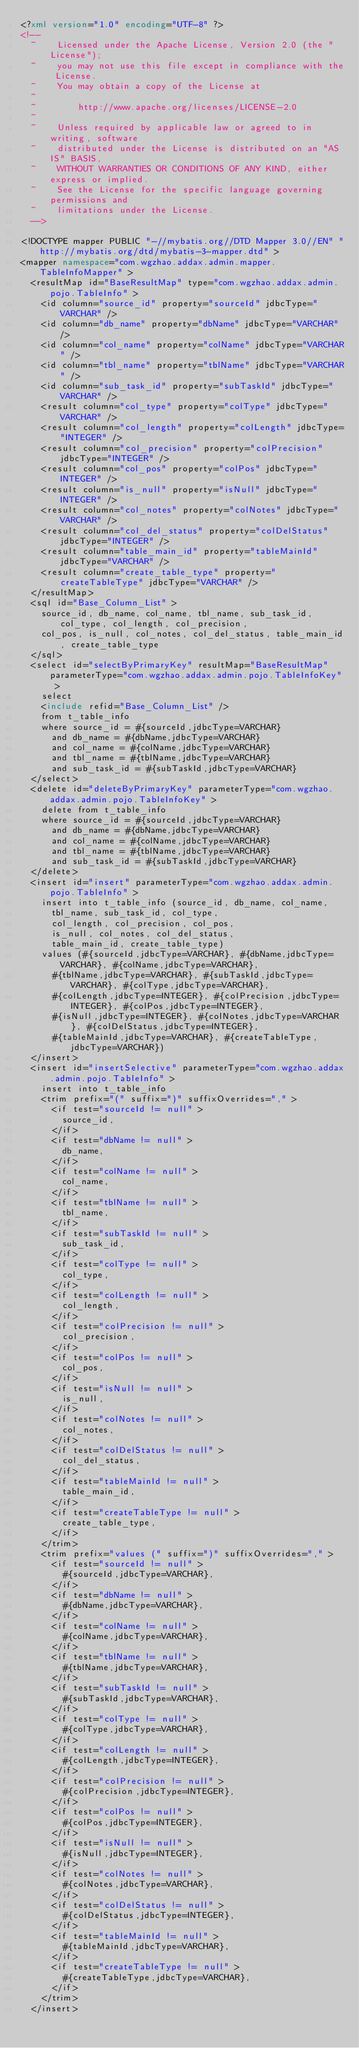Convert code to text. <code><loc_0><loc_0><loc_500><loc_500><_XML_><?xml version="1.0" encoding="UTF-8" ?>
<!--
  ~    Licensed under the Apache License, Version 2.0 (the "License");
  ~    you may not use this file except in compliance with the License.
  ~    You may obtain a copy of the License at
  ~
  ~        http://www.apache.org/licenses/LICENSE-2.0
  ~
  ~    Unless required by applicable law or agreed to in writing, software
  ~    distributed under the License is distributed on an "AS IS" BASIS,
  ~    WITHOUT WARRANTIES OR CONDITIONS OF ANY KIND, either express or implied.
  ~    See the License for the specific language governing permissions and
  ~    limitations under the License.
  -->

<!DOCTYPE mapper PUBLIC "-//mybatis.org//DTD Mapper 3.0//EN" "http://mybatis.org/dtd/mybatis-3-mapper.dtd" >
<mapper namespace="com.wgzhao.addax.admin.mapper.TableInfoMapper" >
  <resultMap id="BaseResultMap" type="com.wgzhao.addax.admin.pojo.TableInfo" >
    <id column="source_id" property="sourceId" jdbcType="VARCHAR" />
    <id column="db_name" property="dbName" jdbcType="VARCHAR" />
    <id column="col_name" property="colName" jdbcType="VARCHAR" />
    <id column="tbl_name" property="tblName" jdbcType="VARCHAR" />
    <id column="sub_task_id" property="subTaskId" jdbcType="VARCHAR" />
    <result column="col_type" property="colType" jdbcType="VARCHAR" />
    <result column="col_length" property="colLength" jdbcType="INTEGER" />
    <result column="col_precision" property="colPrecision" jdbcType="INTEGER" />
    <result column="col_pos" property="colPos" jdbcType="INTEGER" />
    <result column="is_null" property="isNull" jdbcType="INTEGER" />
    <result column="col_notes" property="colNotes" jdbcType="VARCHAR" />
    <result column="col_del_status" property="colDelStatus" jdbcType="INTEGER" />
    <result column="table_main_id" property="tableMainId" jdbcType="VARCHAR" />
    <result column="create_table_type" property="createTableType" jdbcType="VARCHAR" />
  </resultMap>
  <sql id="Base_Column_List" >
    source_id, db_name, col_name, tbl_name, sub_task_id, col_type, col_length, col_precision, 
    col_pos, is_null, col_notes, col_del_status, table_main_id, create_table_type
  </sql>
  <select id="selectByPrimaryKey" resultMap="BaseResultMap" parameterType="com.wgzhao.addax.admin.pojo.TableInfoKey" >
    select 
    <include refid="Base_Column_List" />
    from t_table_info
    where source_id = #{sourceId,jdbcType=VARCHAR}
      and db_name = #{dbName,jdbcType=VARCHAR}
      and col_name = #{colName,jdbcType=VARCHAR}
      and tbl_name = #{tblName,jdbcType=VARCHAR}
      and sub_task_id = #{subTaskId,jdbcType=VARCHAR}
  </select>
  <delete id="deleteByPrimaryKey" parameterType="com.wgzhao.addax.admin.pojo.TableInfoKey" >
    delete from t_table_info
    where source_id = #{sourceId,jdbcType=VARCHAR}
      and db_name = #{dbName,jdbcType=VARCHAR}
      and col_name = #{colName,jdbcType=VARCHAR}
      and tbl_name = #{tblName,jdbcType=VARCHAR}
      and sub_task_id = #{subTaskId,jdbcType=VARCHAR}
  </delete>
  <insert id="insert" parameterType="com.wgzhao.addax.admin.pojo.TableInfo" >
    insert into t_table_info (source_id, db_name, col_name, 
      tbl_name, sub_task_id, col_type, 
      col_length, col_precision, col_pos, 
      is_null, col_notes, col_del_status, 
      table_main_id, create_table_type)
    values (#{sourceId,jdbcType=VARCHAR}, #{dbName,jdbcType=VARCHAR}, #{colName,jdbcType=VARCHAR}, 
      #{tblName,jdbcType=VARCHAR}, #{subTaskId,jdbcType=VARCHAR}, #{colType,jdbcType=VARCHAR}, 
      #{colLength,jdbcType=INTEGER}, #{colPrecision,jdbcType=INTEGER}, #{colPos,jdbcType=INTEGER}, 
      #{isNull,jdbcType=INTEGER}, #{colNotes,jdbcType=VARCHAR}, #{colDelStatus,jdbcType=INTEGER}, 
      #{tableMainId,jdbcType=VARCHAR}, #{createTableType,jdbcType=VARCHAR})
  </insert>
  <insert id="insertSelective" parameterType="com.wgzhao.addax.admin.pojo.TableInfo" >
    insert into t_table_info
    <trim prefix="(" suffix=")" suffixOverrides="," >
      <if test="sourceId != null" >
        source_id,
      </if>
      <if test="dbName != null" >
        db_name,
      </if>
      <if test="colName != null" >
        col_name,
      </if>
      <if test="tblName != null" >
        tbl_name,
      </if>
      <if test="subTaskId != null" >
        sub_task_id,
      </if>
      <if test="colType != null" >
        col_type,
      </if>
      <if test="colLength != null" >
        col_length,
      </if>
      <if test="colPrecision != null" >
        col_precision,
      </if>
      <if test="colPos != null" >
        col_pos,
      </if>
      <if test="isNull != null" >
        is_null,
      </if>
      <if test="colNotes != null" >
        col_notes,
      </if>
      <if test="colDelStatus != null" >
        col_del_status,
      </if>
      <if test="tableMainId != null" >
        table_main_id,
      </if>
      <if test="createTableType != null" >
        create_table_type,
      </if>
    </trim>
    <trim prefix="values (" suffix=")" suffixOverrides="," >
      <if test="sourceId != null" >
        #{sourceId,jdbcType=VARCHAR},
      </if>
      <if test="dbName != null" >
        #{dbName,jdbcType=VARCHAR},
      </if>
      <if test="colName != null" >
        #{colName,jdbcType=VARCHAR},
      </if>
      <if test="tblName != null" >
        #{tblName,jdbcType=VARCHAR},
      </if>
      <if test="subTaskId != null" >
        #{subTaskId,jdbcType=VARCHAR},
      </if>
      <if test="colType != null" >
        #{colType,jdbcType=VARCHAR},
      </if>
      <if test="colLength != null" >
        #{colLength,jdbcType=INTEGER},
      </if>
      <if test="colPrecision != null" >
        #{colPrecision,jdbcType=INTEGER},
      </if>
      <if test="colPos != null" >
        #{colPos,jdbcType=INTEGER},
      </if>
      <if test="isNull != null" >
        #{isNull,jdbcType=INTEGER},
      </if>
      <if test="colNotes != null" >
        #{colNotes,jdbcType=VARCHAR},
      </if>
      <if test="colDelStatus != null" >
        #{colDelStatus,jdbcType=INTEGER},
      </if>
      <if test="tableMainId != null" >
        #{tableMainId,jdbcType=VARCHAR},
      </if>
      <if test="createTableType != null" >
        #{createTableType,jdbcType=VARCHAR},
      </if>
    </trim>
  </insert></code> 